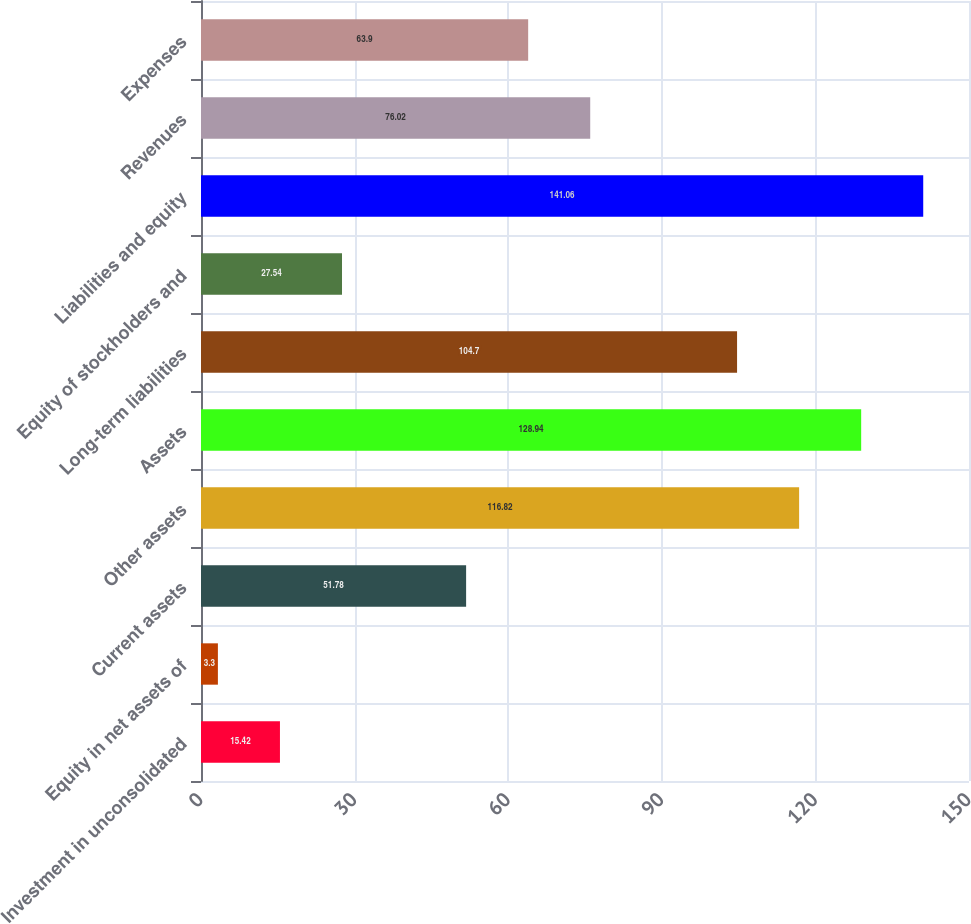<chart> <loc_0><loc_0><loc_500><loc_500><bar_chart><fcel>Investment in unconsolidated<fcel>Equity in net assets of<fcel>Current assets<fcel>Other assets<fcel>Assets<fcel>Long-term liabilities<fcel>Equity of stockholders and<fcel>Liabilities and equity<fcel>Revenues<fcel>Expenses<nl><fcel>15.42<fcel>3.3<fcel>51.78<fcel>116.82<fcel>128.94<fcel>104.7<fcel>27.54<fcel>141.06<fcel>76.02<fcel>63.9<nl></chart> 